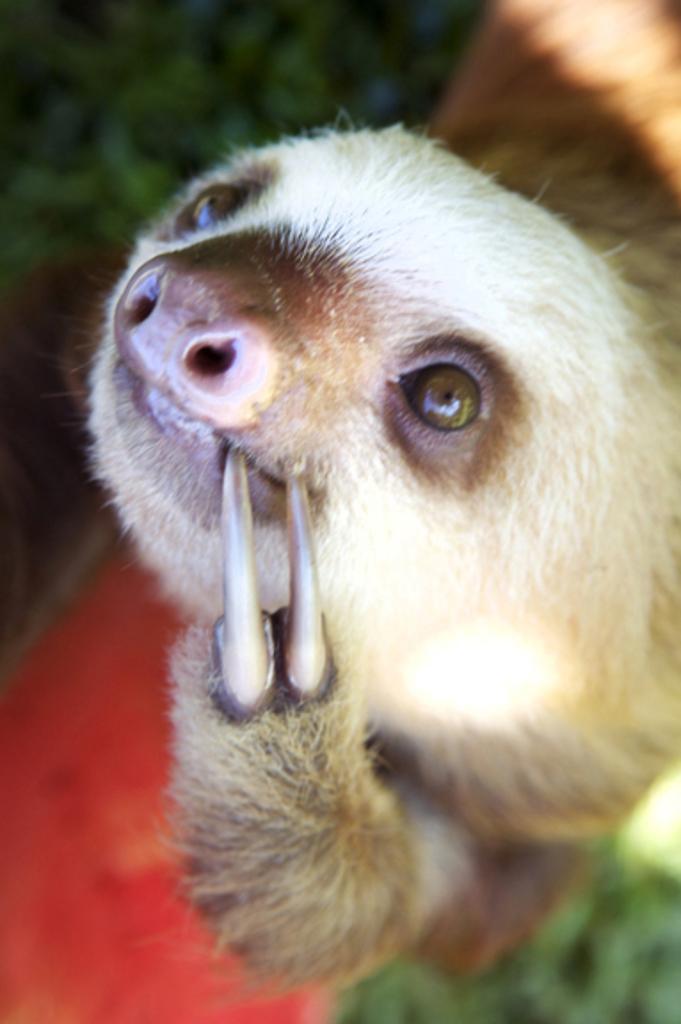Could you give a brief overview of what you see in this image? In this image the background is a little blurred. In the middle of the image there is an animal. 